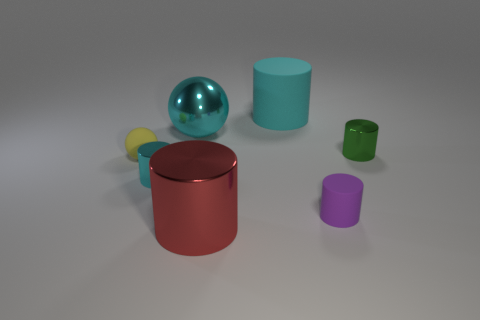Subtract all large red cylinders. How many cylinders are left? 4 Subtract all purple cylinders. How many cylinders are left? 4 Subtract all spheres. How many objects are left? 5 Subtract 1 cylinders. How many cylinders are left? 4 Add 1 red cylinders. How many objects exist? 8 Subtract all cyan spheres. How many brown cylinders are left? 0 Add 4 cyan things. How many cyan things exist? 7 Subtract 1 red cylinders. How many objects are left? 6 Subtract all red spheres. Subtract all yellow blocks. How many spheres are left? 2 Subtract all cyan rubber things. Subtract all green objects. How many objects are left? 5 